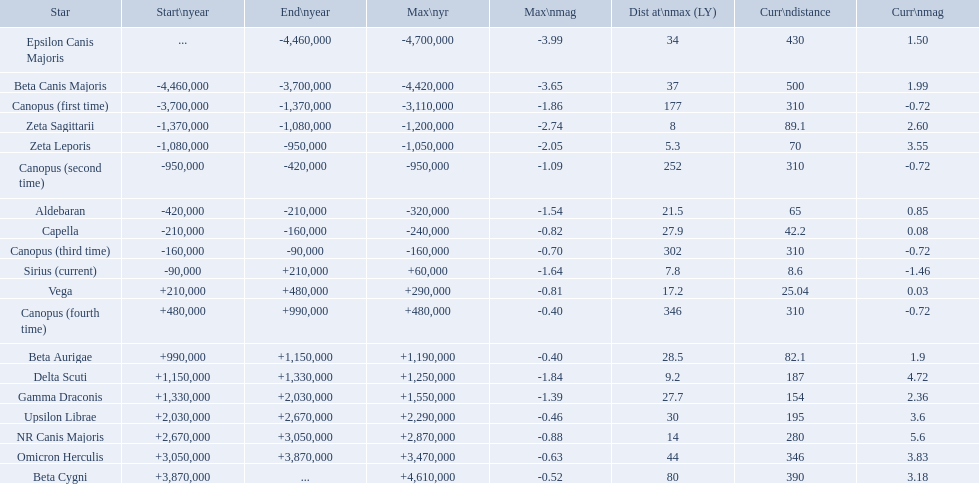What are all the stars? Epsilon Canis Majoris, Beta Canis Majoris, Canopus (first time), Zeta Sagittarii, Zeta Leporis, Canopus (second time), Aldebaran, Capella, Canopus (third time), Sirius (current), Vega, Canopus (fourth time), Beta Aurigae, Delta Scuti, Gamma Draconis, Upsilon Librae, NR Canis Majoris, Omicron Herculis, Beta Cygni. Of those, which star has a maximum distance of 80? Beta Cygni. What are the historical brightest stars? Epsilon Canis Majoris, Beta Canis Majoris, Canopus (first time), Zeta Sagittarii, Zeta Leporis, Canopus (second time), Aldebaran, Capella, Canopus (third time), Sirius (current), Vega, Canopus (fourth time), Beta Aurigae, Delta Scuti, Gamma Draconis, Upsilon Librae, NR Canis Majoris, Omicron Herculis, Beta Cygni. Of those which star has a distance at maximum of 80 Beta Cygni. 